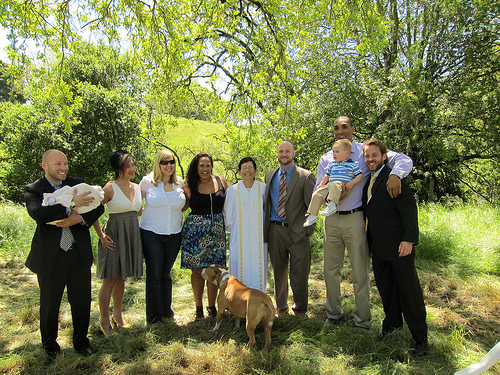<image>
Is there a tree behind the baby? Yes. From this viewpoint, the tree is positioned behind the baby, with the baby partially or fully occluding the tree. Is the dog in front of the woman? Yes. The dog is positioned in front of the woman, appearing closer to the camera viewpoint. 